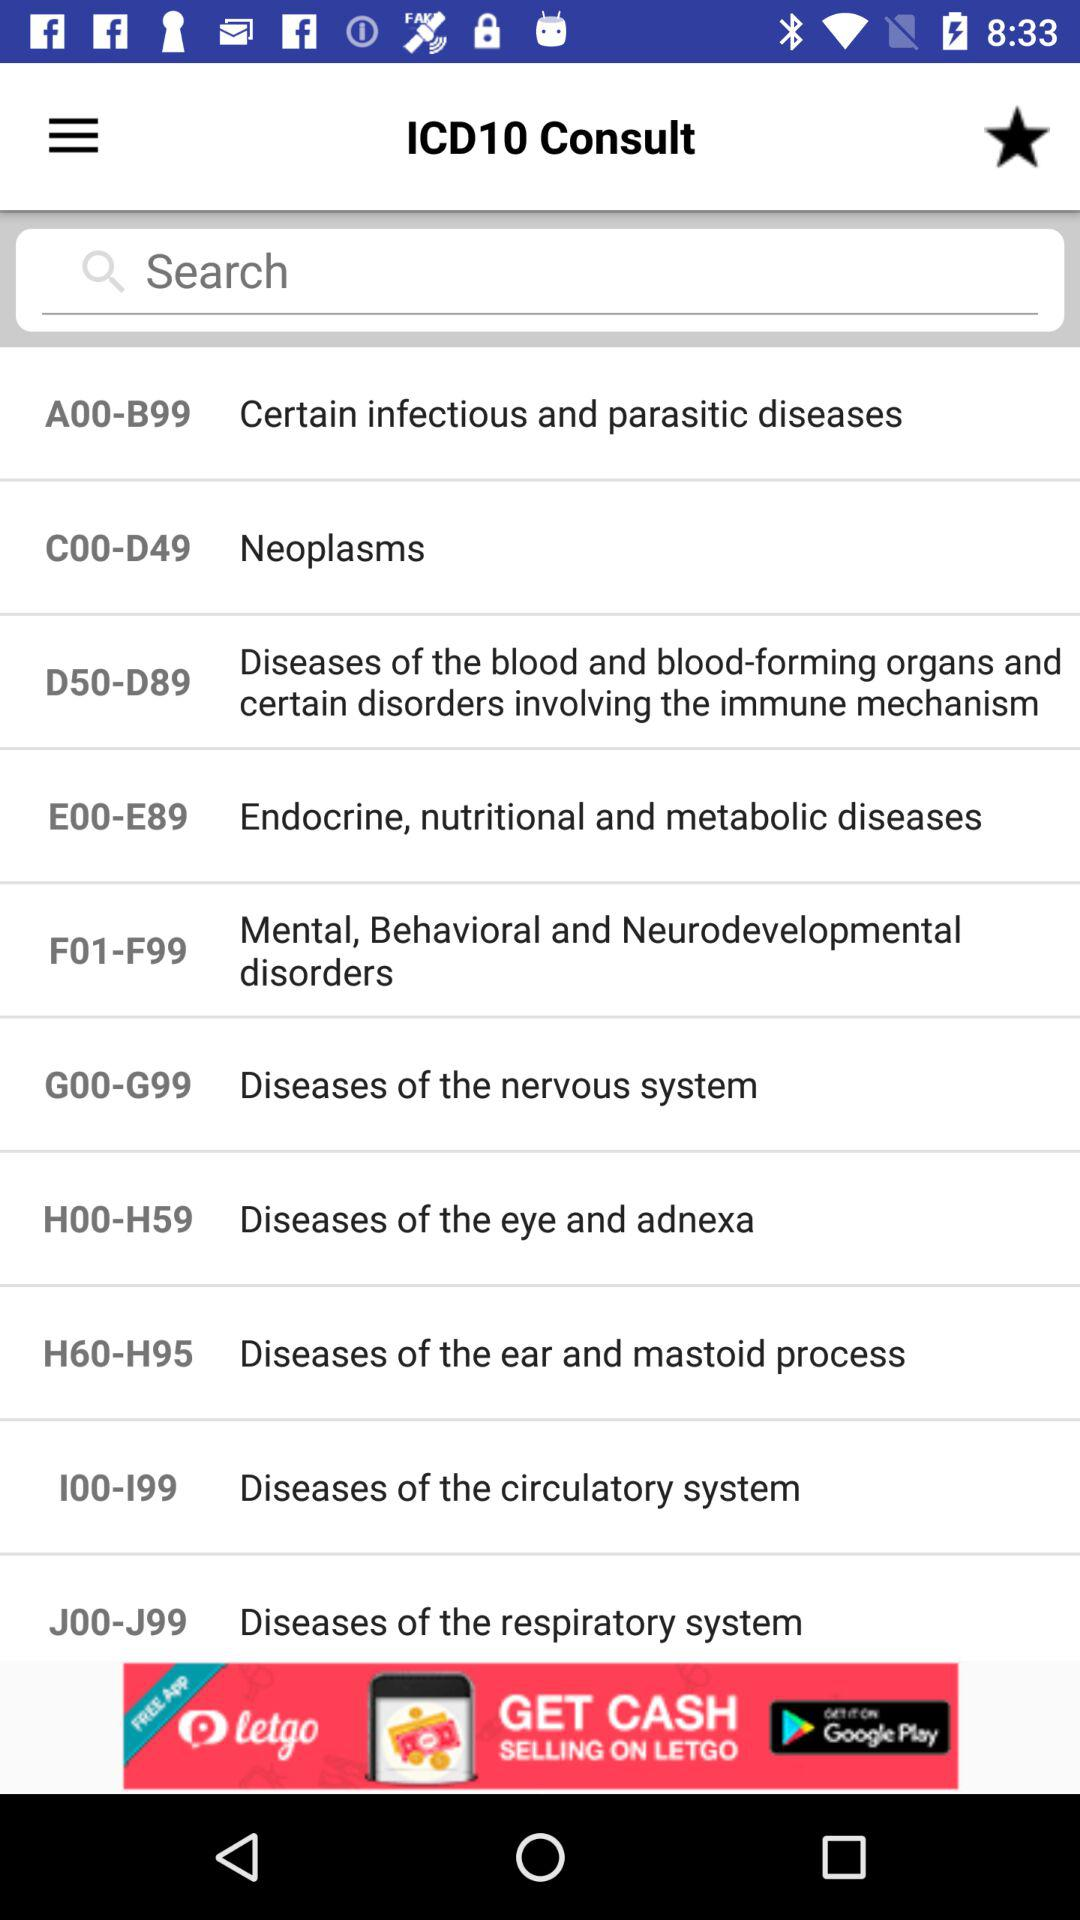What health conditions are represented by ICD codes "H00-H59"? The health condition is "Diseases of the eye and adnexa". 